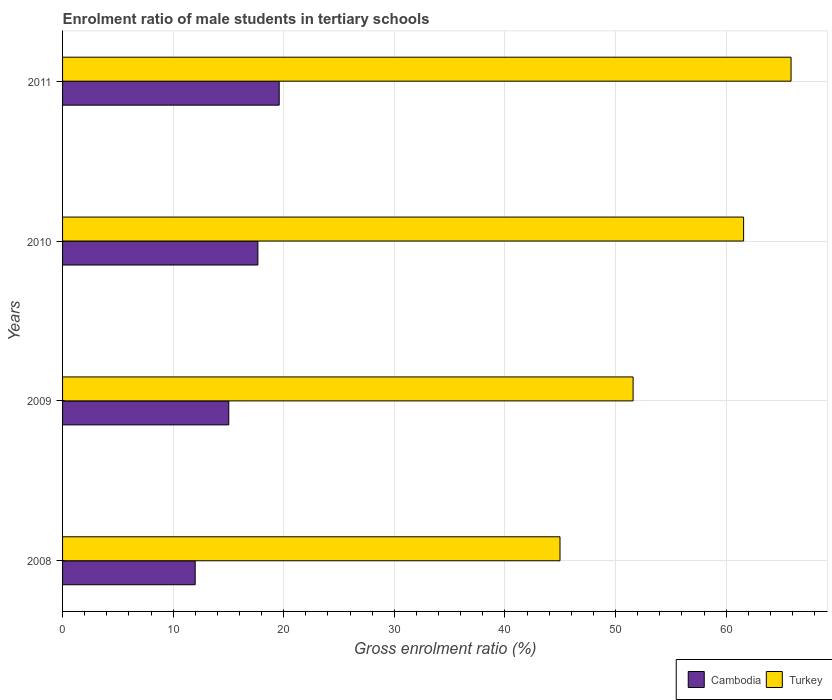How many different coloured bars are there?
Provide a succinct answer. 2. Are the number of bars per tick equal to the number of legend labels?
Provide a succinct answer. Yes. How many bars are there on the 1st tick from the top?
Ensure brevity in your answer.  2. How many bars are there on the 2nd tick from the bottom?
Your answer should be compact. 2. What is the label of the 1st group of bars from the top?
Provide a succinct answer. 2011. In how many cases, is the number of bars for a given year not equal to the number of legend labels?
Your answer should be compact. 0. What is the enrolment ratio of male students in tertiary schools in Turkey in 2011?
Provide a short and direct response. 65.87. Across all years, what is the maximum enrolment ratio of male students in tertiary schools in Turkey?
Your response must be concise. 65.87. Across all years, what is the minimum enrolment ratio of male students in tertiary schools in Turkey?
Make the answer very short. 44.98. In which year was the enrolment ratio of male students in tertiary schools in Turkey minimum?
Provide a succinct answer. 2008. What is the total enrolment ratio of male students in tertiary schools in Cambodia in the graph?
Your response must be concise. 64.27. What is the difference between the enrolment ratio of male students in tertiary schools in Cambodia in 2009 and that in 2011?
Offer a very short reply. -4.56. What is the difference between the enrolment ratio of male students in tertiary schools in Cambodia in 2010 and the enrolment ratio of male students in tertiary schools in Turkey in 2011?
Offer a very short reply. -48.21. What is the average enrolment ratio of male students in tertiary schools in Turkey per year?
Provide a short and direct response. 56.01. In the year 2011, what is the difference between the enrolment ratio of male students in tertiary schools in Cambodia and enrolment ratio of male students in tertiary schools in Turkey?
Your answer should be compact. -46.28. What is the ratio of the enrolment ratio of male students in tertiary schools in Cambodia in 2008 to that in 2010?
Give a very brief answer. 0.68. What is the difference between the highest and the second highest enrolment ratio of male students in tertiary schools in Turkey?
Offer a very short reply. 4.29. What is the difference between the highest and the lowest enrolment ratio of male students in tertiary schools in Turkey?
Offer a very short reply. 20.89. In how many years, is the enrolment ratio of male students in tertiary schools in Cambodia greater than the average enrolment ratio of male students in tertiary schools in Cambodia taken over all years?
Keep it short and to the point. 2. Are all the bars in the graph horizontal?
Provide a short and direct response. Yes. How many years are there in the graph?
Give a very brief answer. 4. What is the difference between two consecutive major ticks on the X-axis?
Make the answer very short. 10. Does the graph contain any zero values?
Your answer should be very brief. No. Where does the legend appear in the graph?
Your answer should be compact. Bottom right. How many legend labels are there?
Offer a terse response. 2. What is the title of the graph?
Provide a short and direct response. Enrolment ratio of male students in tertiary schools. What is the label or title of the X-axis?
Your answer should be very brief. Gross enrolment ratio (%). What is the Gross enrolment ratio (%) of Cambodia in 2008?
Give a very brief answer. 11.99. What is the Gross enrolment ratio (%) in Turkey in 2008?
Provide a succinct answer. 44.98. What is the Gross enrolment ratio (%) of Cambodia in 2009?
Make the answer very short. 15.03. What is the Gross enrolment ratio (%) in Turkey in 2009?
Ensure brevity in your answer.  51.59. What is the Gross enrolment ratio (%) in Cambodia in 2010?
Your response must be concise. 17.66. What is the Gross enrolment ratio (%) of Turkey in 2010?
Give a very brief answer. 61.58. What is the Gross enrolment ratio (%) in Cambodia in 2011?
Make the answer very short. 19.59. What is the Gross enrolment ratio (%) in Turkey in 2011?
Keep it short and to the point. 65.87. Across all years, what is the maximum Gross enrolment ratio (%) in Cambodia?
Make the answer very short. 19.59. Across all years, what is the maximum Gross enrolment ratio (%) in Turkey?
Offer a very short reply. 65.87. Across all years, what is the minimum Gross enrolment ratio (%) of Cambodia?
Provide a short and direct response. 11.99. Across all years, what is the minimum Gross enrolment ratio (%) of Turkey?
Make the answer very short. 44.98. What is the total Gross enrolment ratio (%) of Cambodia in the graph?
Your answer should be compact. 64.27. What is the total Gross enrolment ratio (%) in Turkey in the graph?
Offer a very short reply. 224.02. What is the difference between the Gross enrolment ratio (%) in Cambodia in 2008 and that in 2009?
Ensure brevity in your answer.  -3.04. What is the difference between the Gross enrolment ratio (%) of Turkey in 2008 and that in 2009?
Keep it short and to the point. -6.61. What is the difference between the Gross enrolment ratio (%) of Cambodia in 2008 and that in 2010?
Provide a short and direct response. -5.67. What is the difference between the Gross enrolment ratio (%) in Turkey in 2008 and that in 2010?
Provide a succinct answer. -16.6. What is the difference between the Gross enrolment ratio (%) in Cambodia in 2008 and that in 2011?
Offer a very short reply. -7.6. What is the difference between the Gross enrolment ratio (%) in Turkey in 2008 and that in 2011?
Your answer should be compact. -20.89. What is the difference between the Gross enrolment ratio (%) of Cambodia in 2009 and that in 2010?
Ensure brevity in your answer.  -2.63. What is the difference between the Gross enrolment ratio (%) in Turkey in 2009 and that in 2010?
Your answer should be very brief. -9.99. What is the difference between the Gross enrolment ratio (%) of Cambodia in 2009 and that in 2011?
Give a very brief answer. -4.56. What is the difference between the Gross enrolment ratio (%) of Turkey in 2009 and that in 2011?
Keep it short and to the point. -14.29. What is the difference between the Gross enrolment ratio (%) of Cambodia in 2010 and that in 2011?
Your answer should be very brief. -1.93. What is the difference between the Gross enrolment ratio (%) in Turkey in 2010 and that in 2011?
Offer a terse response. -4.29. What is the difference between the Gross enrolment ratio (%) of Cambodia in 2008 and the Gross enrolment ratio (%) of Turkey in 2009?
Provide a succinct answer. -39.6. What is the difference between the Gross enrolment ratio (%) in Cambodia in 2008 and the Gross enrolment ratio (%) in Turkey in 2010?
Make the answer very short. -49.59. What is the difference between the Gross enrolment ratio (%) of Cambodia in 2008 and the Gross enrolment ratio (%) of Turkey in 2011?
Provide a short and direct response. -53.88. What is the difference between the Gross enrolment ratio (%) of Cambodia in 2009 and the Gross enrolment ratio (%) of Turkey in 2010?
Provide a short and direct response. -46.55. What is the difference between the Gross enrolment ratio (%) of Cambodia in 2009 and the Gross enrolment ratio (%) of Turkey in 2011?
Provide a short and direct response. -50.84. What is the difference between the Gross enrolment ratio (%) of Cambodia in 2010 and the Gross enrolment ratio (%) of Turkey in 2011?
Keep it short and to the point. -48.21. What is the average Gross enrolment ratio (%) in Cambodia per year?
Keep it short and to the point. 16.07. What is the average Gross enrolment ratio (%) in Turkey per year?
Your answer should be very brief. 56.01. In the year 2008, what is the difference between the Gross enrolment ratio (%) of Cambodia and Gross enrolment ratio (%) of Turkey?
Provide a succinct answer. -32.99. In the year 2009, what is the difference between the Gross enrolment ratio (%) of Cambodia and Gross enrolment ratio (%) of Turkey?
Keep it short and to the point. -36.56. In the year 2010, what is the difference between the Gross enrolment ratio (%) of Cambodia and Gross enrolment ratio (%) of Turkey?
Make the answer very short. -43.92. In the year 2011, what is the difference between the Gross enrolment ratio (%) of Cambodia and Gross enrolment ratio (%) of Turkey?
Keep it short and to the point. -46.28. What is the ratio of the Gross enrolment ratio (%) of Cambodia in 2008 to that in 2009?
Make the answer very short. 0.8. What is the ratio of the Gross enrolment ratio (%) of Turkey in 2008 to that in 2009?
Offer a very short reply. 0.87. What is the ratio of the Gross enrolment ratio (%) in Cambodia in 2008 to that in 2010?
Your response must be concise. 0.68. What is the ratio of the Gross enrolment ratio (%) of Turkey in 2008 to that in 2010?
Offer a very short reply. 0.73. What is the ratio of the Gross enrolment ratio (%) of Cambodia in 2008 to that in 2011?
Offer a very short reply. 0.61. What is the ratio of the Gross enrolment ratio (%) of Turkey in 2008 to that in 2011?
Make the answer very short. 0.68. What is the ratio of the Gross enrolment ratio (%) in Cambodia in 2009 to that in 2010?
Offer a terse response. 0.85. What is the ratio of the Gross enrolment ratio (%) of Turkey in 2009 to that in 2010?
Offer a very short reply. 0.84. What is the ratio of the Gross enrolment ratio (%) in Cambodia in 2009 to that in 2011?
Make the answer very short. 0.77. What is the ratio of the Gross enrolment ratio (%) in Turkey in 2009 to that in 2011?
Keep it short and to the point. 0.78. What is the ratio of the Gross enrolment ratio (%) in Cambodia in 2010 to that in 2011?
Your response must be concise. 0.9. What is the ratio of the Gross enrolment ratio (%) of Turkey in 2010 to that in 2011?
Your response must be concise. 0.93. What is the difference between the highest and the second highest Gross enrolment ratio (%) of Cambodia?
Your response must be concise. 1.93. What is the difference between the highest and the second highest Gross enrolment ratio (%) of Turkey?
Offer a terse response. 4.29. What is the difference between the highest and the lowest Gross enrolment ratio (%) of Cambodia?
Keep it short and to the point. 7.6. What is the difference between the highest and the lowest Gross enrolment ratio (%) of Turkey?
Offer a very short reply. 20.89. 